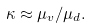Convert formula to latex. <formula><loc_0><loc_0><loc_500><loc_500>\kappa \approx \mu _ { v } / \mu _ { d } .</formula> 